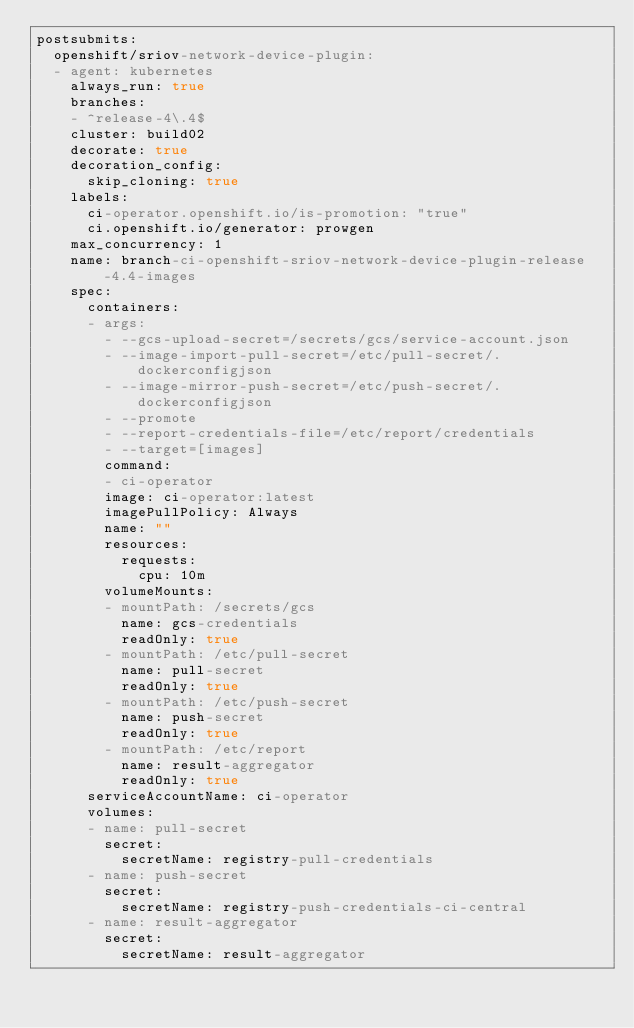<code> <loc_0><loc_0><loc_500><loc_500><_YAML_>postsubmits:
  openshift/sriov-network-device-plugin:
  - agent: kubernetes
    always_run: true
    branches:
    - ^release-4\.4$
    cluster: build02
    decorate: true
    decoration_config:
      skip_cloning: true
    labels:
      ci-operator.openshift.io/is-promotion: "true"
      ci.openshift.io/generator: prowgen
    max_concurrency: 1
    name: branch-ci-openshift-sriov-network-device-plugin-release-4.4-images
    spec:
      containers:
      - args:
        - --gcs-upload-secret=/secrets/gcs/service-account.json
        - --image-import-pull-secret=/etc/pull-secret/.dockerconfigjson
        - --image-mirror-push-secret=/etc/push-secret/.dockerconfigjson
        - --promote
        - --report-credentials-file=/etc/report/credentials
        - --target=[images]
        command:
        - ci-operator
        image: ci-operator:latest
        imagePullPolicy: Always
        name: ""
        resources:
          requests:
            cpu: 10m
        volumeMounts:
        - mountPath: /secrets/gcs
          name: gcs-credentials
          readOnly: true
        - mountPath: /etc/pull-secret
          name: pull-secret
          readOnly: true
        - mountPath: /etc/push-secret
          name: push-secret
          readOnly: true
        - mountPath: /etc/report
          name: result-aggregator
          readOnly: true
      serviceAccountName: ci-operator
      volumes:
      - name: pull-secret
        secret:
          secretName: registry-pull-credentials
      - name: push-secret
        secret:
          secretName: registry-push-credentials-ci-central
      - name: result-aggregator
        secret:
          secretName: result-aggregator
</code> 